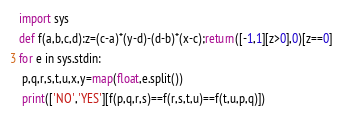<code> <loc_0><loc_0><loc_500><loc_500><_Python_>import sys
def f(a,b,c,d):z=(c-a)*(y-d)-(d-b)*(x-c);return([-1,1][z>0],0)[z==0]
for e in sys.stdin:
 p,q,r,s,t,u,x,y=map(float,e.split())
 print(['NO','YES'][f(p,q,r,s)==f(r,s,t,u)==f(t,u,p,q)])
</code> 